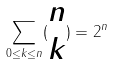Convert formula to latex. <formula><loc_0><loc_0><loc_500><loc_500>\sum _ { 0 \leq k \leq n } ( \begin{matrix} n \\ k \end{matrix} ) = 2 ^ { n }</formula> 